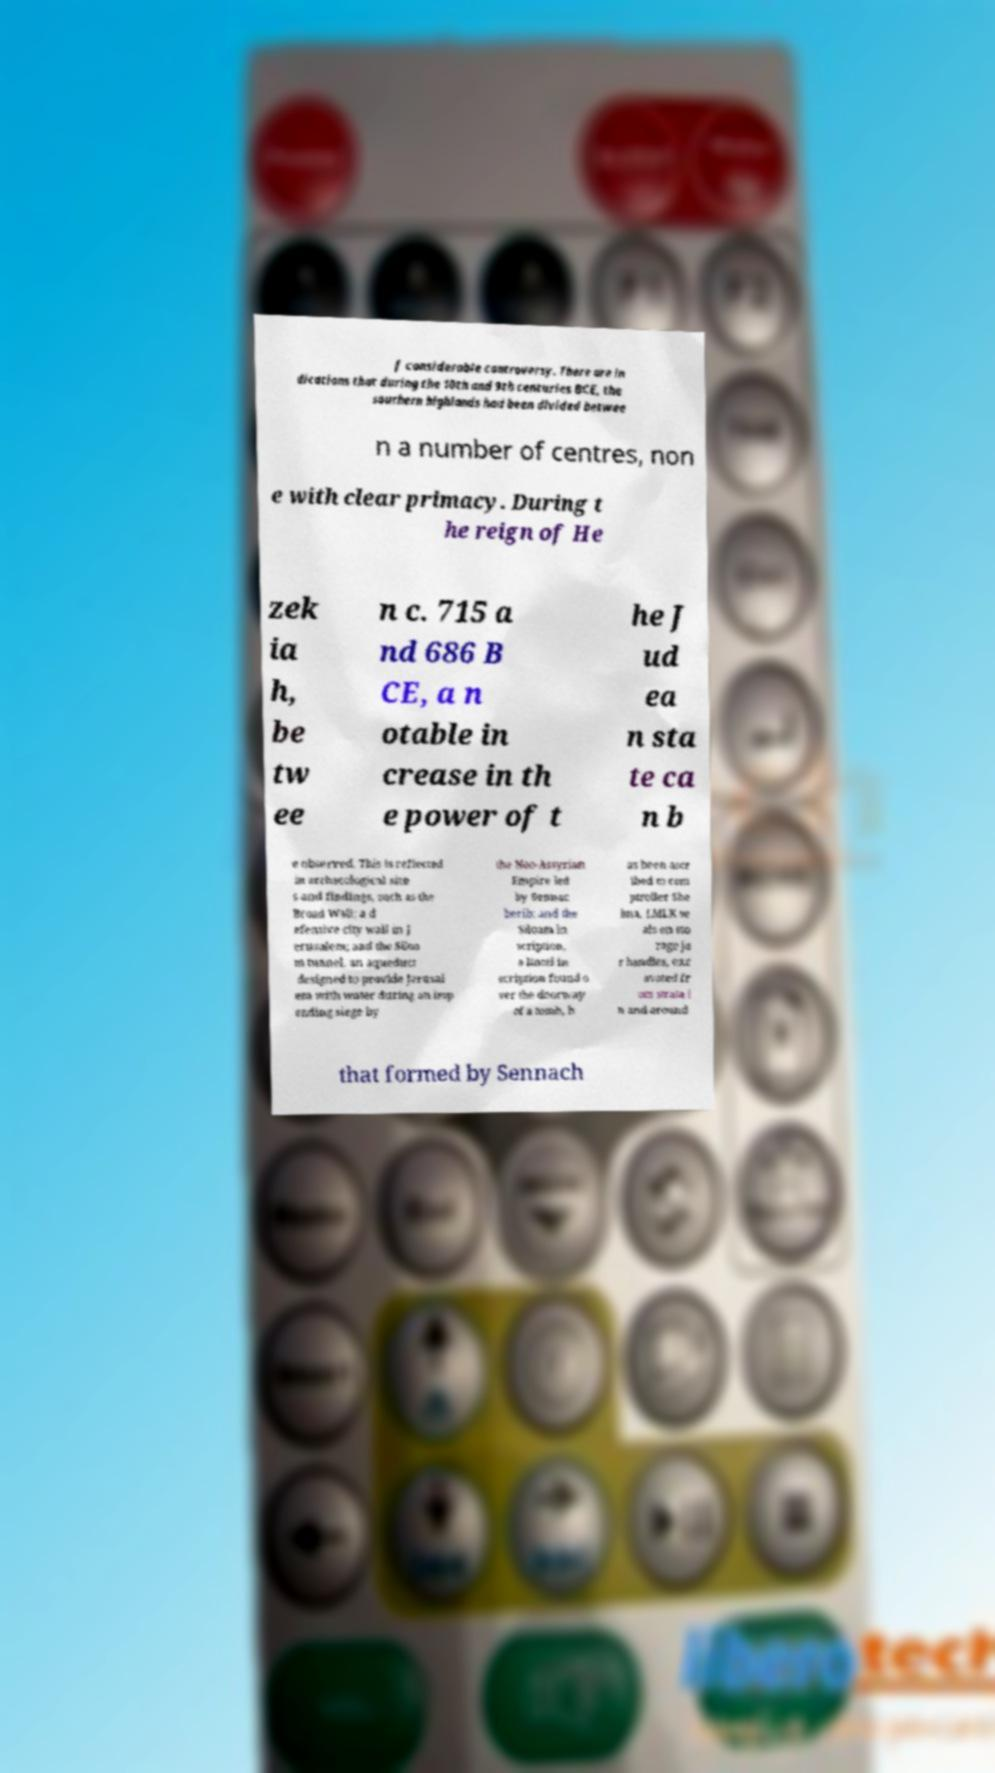Could you assist in decoding the text presented in this image and type it out clearly? f considerable controversy. There are in dications that during the 10th and 9th centuries BCE, the southern highlands had been divided betwee n a number of centres, non e with clear primacy. During t he reign of He zek ia h, be tw ee n c. 715 a nd 686 B CE, a n otable in crease in th e power of t he J ud ea n sta te ca n b e observed. This is reflected in archaeological site s and findings, such as the Broad Wall; a d efensive city wall in J erusalem; and the Siloa m tunnel, an aqueduct designed to provide Jerusal em with water during an imp ending siege by the Neo-Assyrian Empire led by Sennac herib; and the Siloam in scription, a lintel in scription found o ver the doorway of a tomb, h as been ascr ibed to com ptroller She bna. LMLK se als on sto rage ja r handles, exc avated fr om strata i n and around that formed by Sennach 